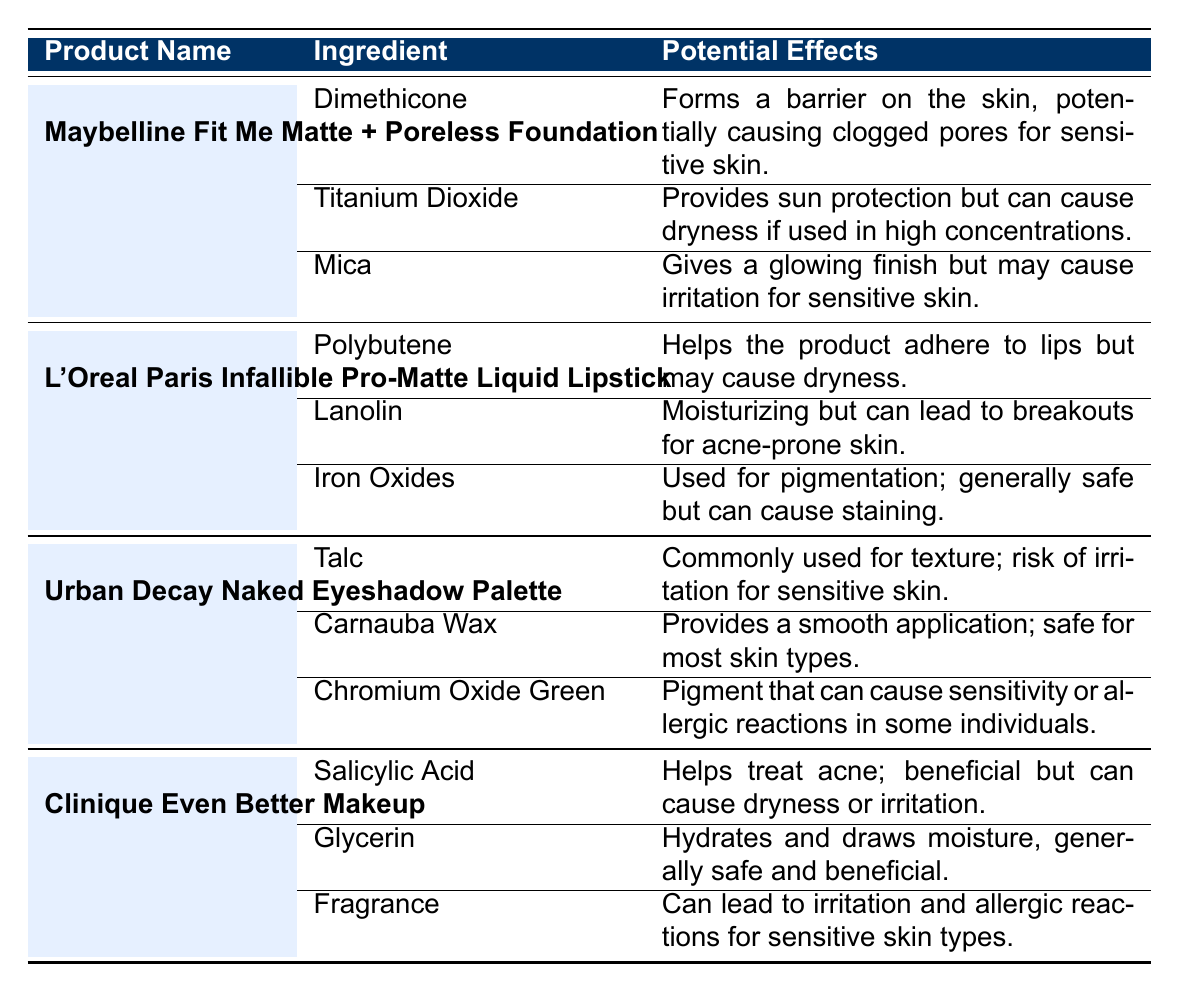What are the potential effects of Dimethicone in Maybelline Fit Me Matte + Poreless Foundation? The table states that Dimethicone forms a barrier on the skin and may cause clogged pores for sensitive skin.
Answer: Forms a barrier; may cause clogged pores Which ingredient in L'Oreal Paris Infallible Pro-Matte Liquid Lipstick is moisturizing? The ingredient Lanolin is identified as moisturizing but may lead to breakouts for acne-prone skin.
Answer: Lanolin True or False: Salicylic Acid in Clinique Even Better Makeup is beneficial for treating acne. The table indicates that Salicylic Acid helps treat acne, so this statement is true.
Answer: True What is the common risk associated with Talc in Urban Decay Naked Eyeshadow Palette? The table identifies the risk associated with Talc as a potential irritation for sensitive skin.
Answer: Risk of irritation Which product has Glycerin listed as an ingredient? The table shows that Glycerin is an ingredient in Clinique Even Better Makeup.
Answer: Clinique Even Better Makeup What are the potential effects combined for Titanium Dioxide and Mica in Maybelline Fit Me Matte + Poreless Foundation? Titanium Dioxide provides sun protection but can cause dryness, while Mica gives a glowing finish but may irritate sensitive skin; both can affect overall skin health positively and negatively.
Answer: Sun protection; potential dryness; glowing finish; potential irritation How many ingredients in L'Oreal Paris Infallible Pro-Matte Liquid Lipstick have potential effects related to dryness? Polybutene and Lanolin both have potential effects related to dryness, leading to a total of 2 ingredients.
Answer: 2 ingredients Does Chromium Oxide Green cause sensitivity in any individuals? The table notes that Chromium Oxide Green can cause sensitivity or allergic reactions in some individuals, so this is true.
Answer: Yes 